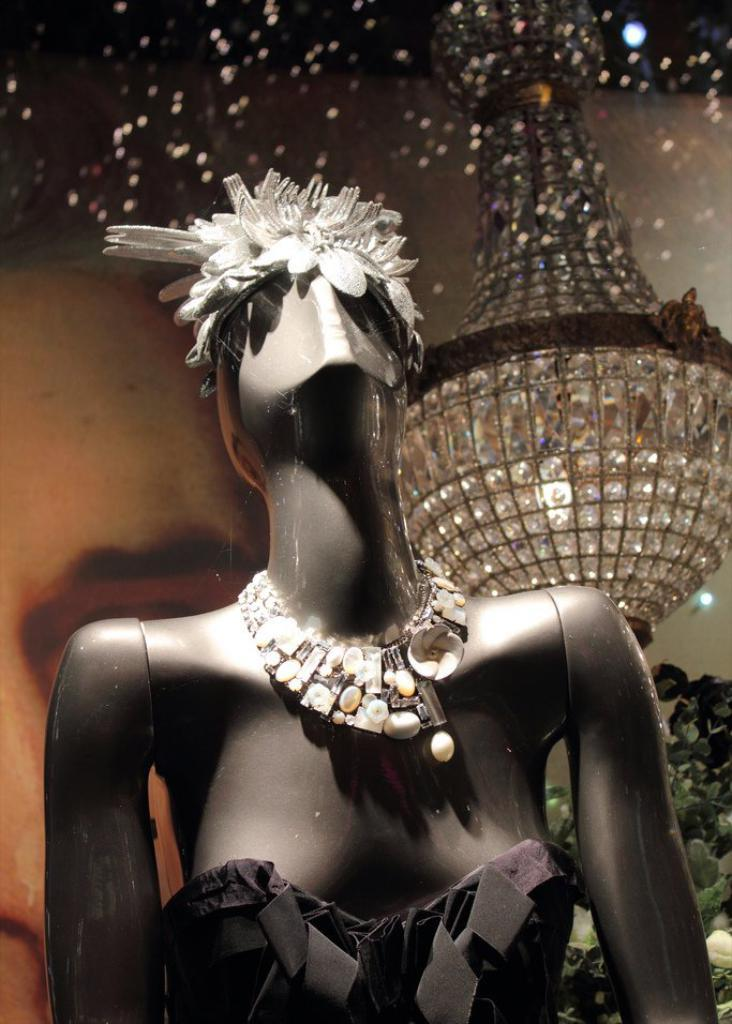What is the main subject of the image? There is a mannequin in the image. What is the mannequin wearing on its head? The mannequin is wearing a crown. What type of jewelry is the mannequin wearing? The mannequin is wearing a necklace. What color is the dress the mannequin is wearing? The mannequin is wearing a black dress. What is located behind the mannequin in the image? There is a glass behind the mannequin. What can be seen hanging from the ceiling behind the glass? There is a large light hanging from the ceiling behind the glass. What type of leather is being mined in the image? There is no mention of leather or mining in the image; it features a mannequin wearing a crown, necklace, and black dress, with a glass and large light behind it. 